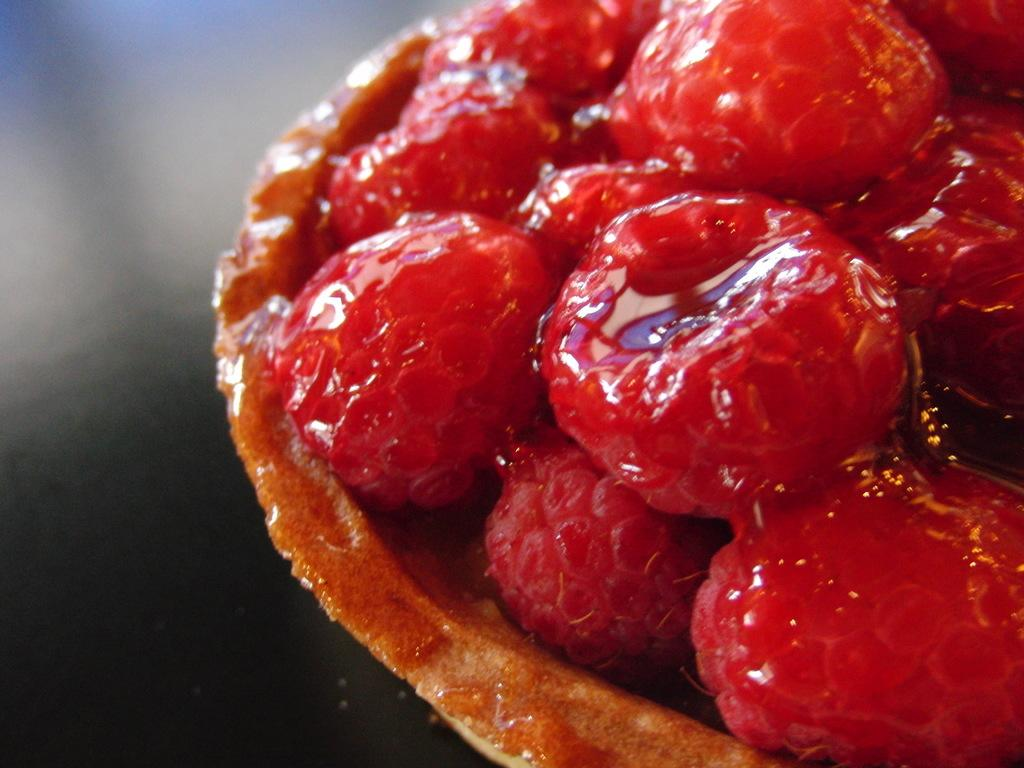What type of fruit is present in the image? There are raspberries in the image. How are the raspberries arranged or contained in the image? The raspberries are in a bowl. Where is the bowl with raspberries located in the image? The bowl is on a table. What is the rate of silk production in the image? There is no mention of silk or any production in the image; it features raspberries in a bowl on a table. 